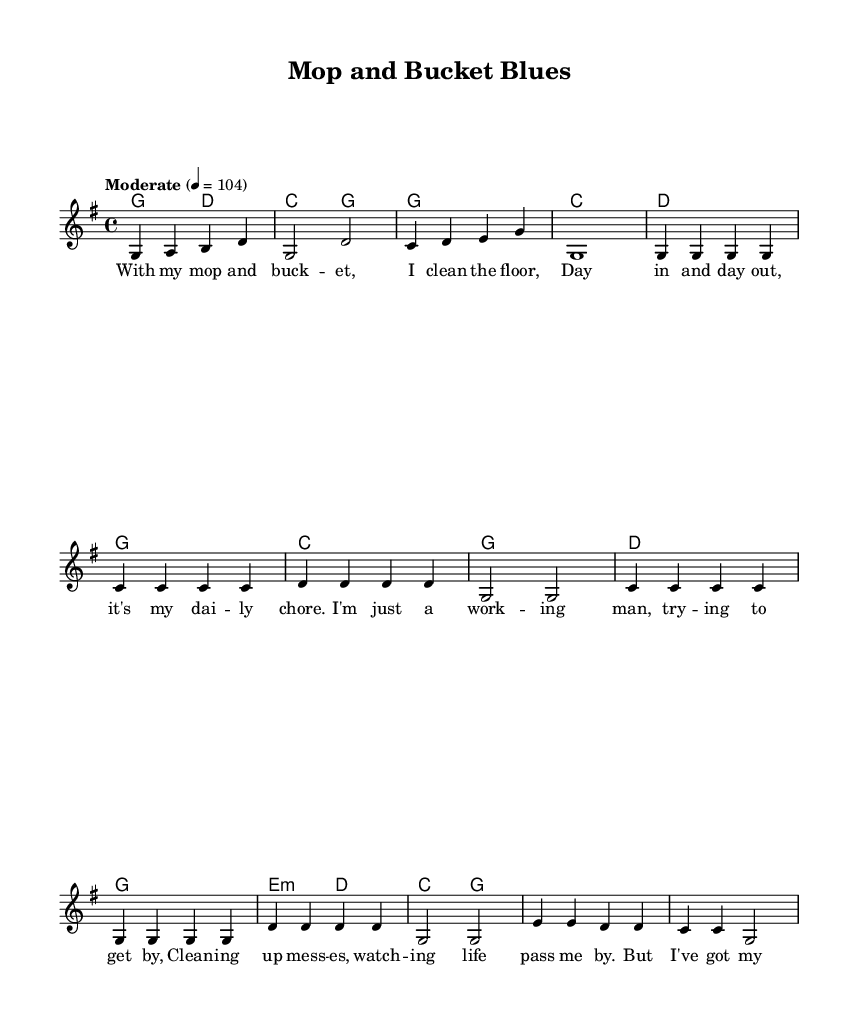What is the key signature of this music? The key signature indicates G major, which includes one sharp (F#). This can be deduced from the `\key g \major` in the global settings.
Answer: G major What is the time signature of this music? The time signature of the piece is 4/4, shown by the `\time 4/4` in the global settings. This means there are four beats per measure, and the quarter note receives one beat.
Answer: 4/4 What is the tempo marking of this music? The tempo marking is set to "Moderate" with a metronome marking of 104 beats per minute, found in the global settings. This indicates the speed at which the piece should be played.
Answer: Moderate 4 = 104 How many measures are in the chorus of this music? The chorus consists of 4 measures as indicated in the slice of the musical notation, encompassing the four lines of notes.
Answer: 4 Which lyric section follows the first verse? The chorus follows the first verse according to the arrangement and structure outlined in the score, where it clearly states that the chorus lyrics come after the first verse.
Answer: Chorus What is the theme of the song? The song's theme revolves around the experiences of a working-class individual, focusing on struggles and pride in their blue-collar job. This is reflected in the lyrics and the title "Mop and Bucket Blues."
Answer: Working-class struggles 